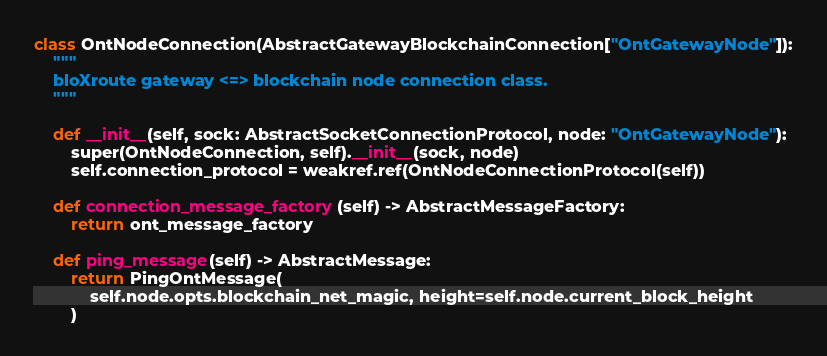Convert code to text. <code><loc_0><loc_0><loc_500><loc_500><_Python_>class OntNodeConnection(AbstractGatewayBlockchainConnection["OntGatewayNode"]):
    """
    bloXroute gateway <=> blockchain node connection class.
    """

    def __init__(self, sock: AbstractSocketConnectionProtocol, node: "OntGatewayNode"):
        super(OntNodeConnection, self).__init__(sock, node)
        self.connection_protocol = weakref.ref(OntNodeConnectionProtocol(self))

    def connection_message_factory(self) -> AbstractMessageFactory:
        return ont_message_factory

    def ping_message(self) -> AbstractMessage:
        return PingOntMessage(
            self.node.opts.blockchain_net_magic, height=self.node.current_block_height
        )
</code> 